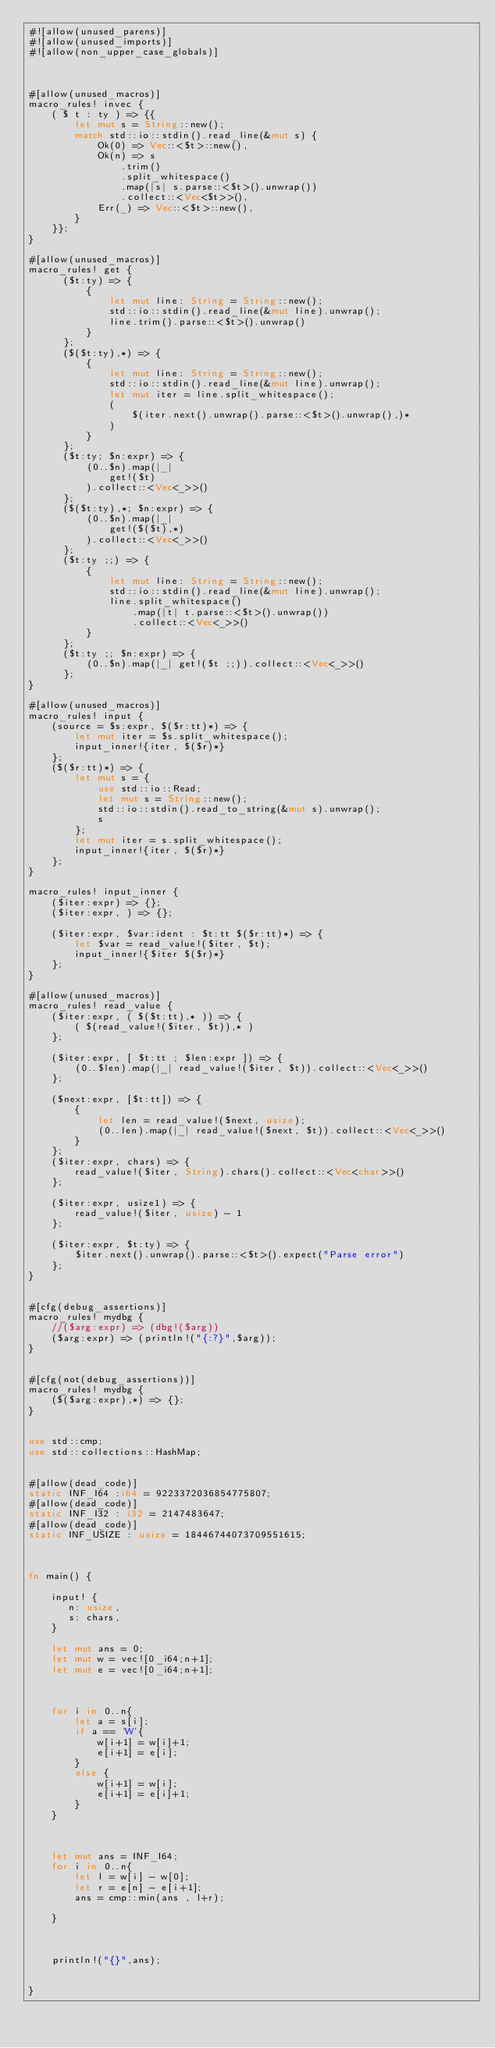<code> <loc_0><loc_0><loc_500><loc_500><_Rust_>#![allow(unused_parens)]
#![allow(unused_imports)]
#![allow(non_upper_case_globals)]



#[allow(unused_macros)]
macro_rules! invec {
    ( $ t : ty ) => {{
        let mut s = String::new();
        match std::io::stdin().read_line(&mut s) {
            Ok(0) => Vec::<$t>::new(),
            Ok(n) => s
                .trim()
                .split_whitespace()
                .map(|s| s.parse::<$t>().unwrap())
                .collect::<Vec<$t>>(),
            Err(_) => Vec::<$t>::new(),
        }
    }};
}

#[allow(unused_macros)]
macro_rules! get {
      ($t:ty) => {
          {
              let mut line: String = String::new();
              std::io::stdin().read_line(&mut line).unwrap();
              line.trim().parse::<$t>().unwrap()
          }
      };
      ($($t:ty),*) => {
          {
              let mut line: String = String::new();
              std::io::stdin().read_line(&mut line).unwrap();
              let mut iter = line.split_whitespace();
              (
                  $(iter.next().unwrap().parse::<$t>().unwrap(),)*
              )
          }
      };
      ($t:ty; $n:expr) => {
          (0..$n).map(|_|
              get!($t)
          ).collect::<Vec<_>>()
      };
      ($($t:ty),*; $n:expr) => {
          (0..$n).map(|_|
              get!($($t),*)
          ).collect::<Vec<_>>()
      };
      ($t:ty ;;) => {
          {
              let mut line: String = String::new();
              std::io::stdin().read_line(&mut line).unwrap();
              line.split_whitespace()
                  .map(|t| t.parse::<$t>().unwrap())
                  .collect::<Vec<_>>()
          }
      };
      ($t:ty ;; $n:expr) => {
          (0..$n).map(|_| get!($t ;;)).collect::<Vec<_>>()
      };
}

#[allow(unused_macros)]
macro_rules! input {
    (source = $s:expr, $($r:tt)*) => {
        let mut iter = $s.split_whitespace();
        input_inner!{iter, $($r)*}
    };
    ($($r:tt)*) => {
        let mut s = {
            use std::io::Read;
            let mut s = String::new();
            std::io::stdin().read_to_string(&mut s).unwrap();
            s
        };
        let mut iter = s.split_whitespace();
        input_inner!{iter, $($r)*}
    };
}

macro_rules! input_inner {
    ($iter:expr) => {};
    ($iter:expr, ) => {};

    ($iter:expr, $var:ident : $t:tt $($r:tt)*) => {
        let $var = read_value!($iter, $t);
        input_inner!{$iter $($r)*}
    };
}

#[allow(unused_macros)]
macro_rules! read_value {
    ($iter:expr, ( $($t:tt),* )) => {
        ( $(read_value!($iter, $t)),* )
    };

    ($iter:expr, [ $t:tt ; $len:expr ]) => {
        (0..$len).map(|_| read_value!($iter, $t)).collect::<Vec<_>>()
    };

    ($next:expr, [$t:tt]) => {
        {
            let len = read_value!($next, usize);
            (0..len).map(|_| read_value!($next, $t)).collect::<Vec<_>>()
        }
    };
    ($iter:expr, chars) => {
        read_value!($iter, String).chars().collect::<Vec<char>>()
    };

    ($iter:expr, usize1) => {
        read_value!($iter, usize) - 1
    };

    ($iter:expr, $t:ty) => {
        $iter.next().unwrap().parse::<$t>().expect("Parse error")
    };
}


#[cfg(debug_assertions)]
macro_rules! mydbg {
    //($arg:expr) => (dbg!($arg))
    ($arg:expr) => (println!("{:?}",$arg));
}


#[cfg(not(debug_assertions))]
macro_rules! mydbg {
    ($($arg:expr),*) => {};
}


use std::cmp;
use std::collections::HashMap;


#[allow(dead_code)]
static INF_I64 :i64 = 9223372036854775807;
#[allow(dead_code)]
static INF_I32 : i32 = 2147483647;
#[allow(dead_code)]
static INF_USIZE : usize = 18446744073709551615;



fn main() {

    input! { 
       n: usize,
       s: chars,
    }

    let mut ans = 0;
    let mut w = vec![0_i64;n+1];
    let mut e = vec![0_i64;n+1];



    for i in 0..n{
        let a = s[i];
        if a == 'W'{
            w[i+1] = w[i]+1;
            e[i+1] = e[i];
        }
        else {
            w[i+1] = w[i];
            e[i+1] = e[i]+1;
        }
    }



    let mut ans = INF_I64;
    for i in 0..n{
        let l = w[i] - w[0];
        let r = e[n] - e[i+1];
        ans = cmp::min(ans , l+r);
        
    }

    
    
    println!("{}",ans);


}
</code> 